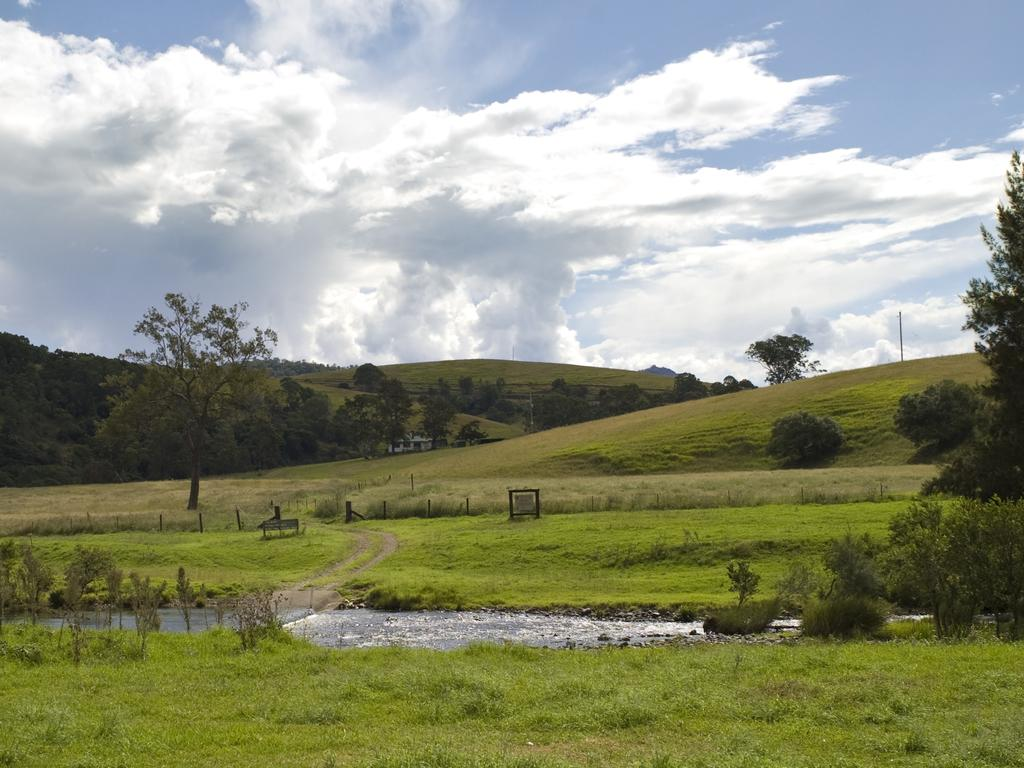What type of vegetation is present on the ground in the image? There are plants and grass on the ground in the image. What can be seen in the image besides the vegetation? There is water visible in the image. What objects are present in the image that are not related to vegetation or water? There are small poles in the image. What can be seen in the background of the image? There are trees, houses, grass, hills, a pole, and clouds in the sky in the background of the image. What type of payment is being made in the image? There is no payment being made in the image; it features plants, grass, water, small poles, and various background elements. What part of the human body is visible in the image? There is no human body visible in the image; it features plants, grass, water, small poles, and various background elements. 